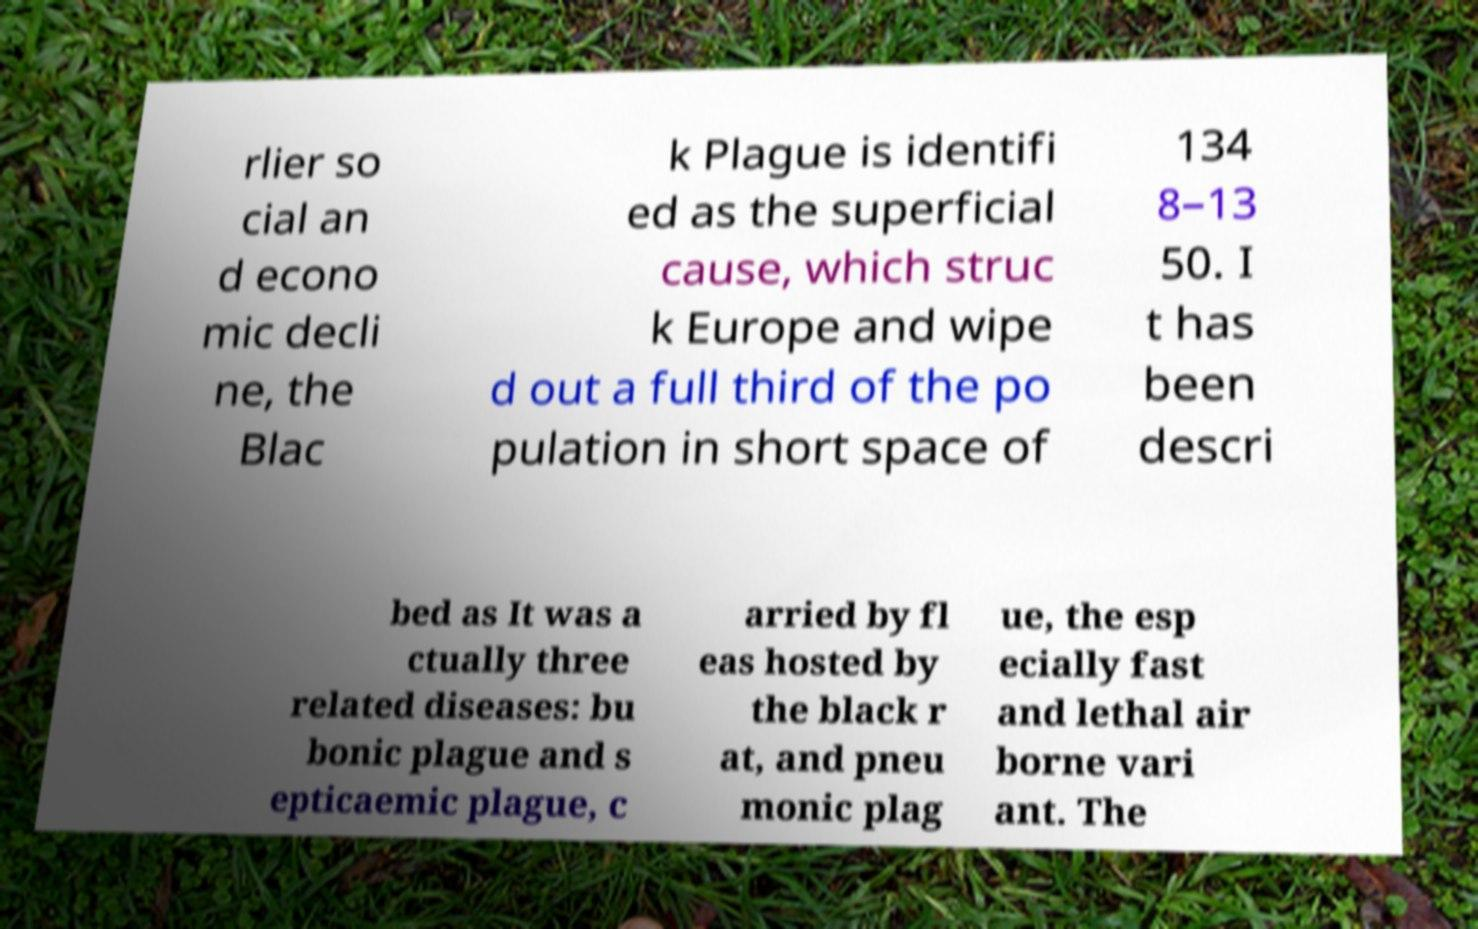Can you read and provide the text displayed in the image?This photo seems to have some interesting text. Can you extract and type it out for me? rlier so cial an d econo mic decli ne, the Blac k Plague is identifi ed as the superficial cause, which struc k Europe and wipe d out a full third of the po pulation in short space of 134 8–13 50. I t has been descri bed as It was a ctually three related diseases: bu bonic plague and s epticaemic plague, c arried by fl eas hosted by the black r at, and pneu monic plag ue, the esp ecially fast and lethal air borne vari ant. The 